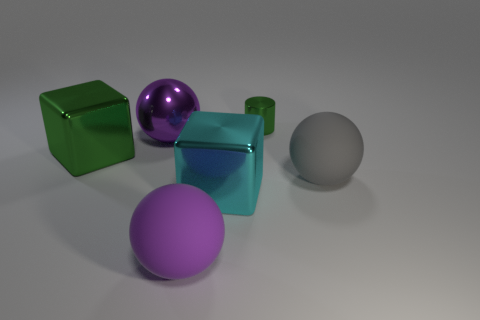What number of gray things are rubber spheres or big matte cylinders?
Your answer should be compact. 1. What is the color of the large metal sphere?
Ensure brevity in your answer.  Purple. The cyan block that is made of the same material as the green cube is what size?
Your response must be concise. Large. What number of other purple things have the same shape as the purple metallic object?
Provide a short and direct response. 1. Are there any other things that have the same size as the metallic cylinder?
Keep it short and to the point. No. What size is the cyan object that is left of the matte object behind the big purple matte object?
Provide a succinct answer. Large. What material is the green thing that is the same size as the purple matte thing?
Provide a short and direct response. Metal. Is there a green cube made of the same material as the tiny cylinder?
Provide a succinct answer. Yes. What is the color of the large matte ball that is in front of the cube in front of the block that is on the left side of the big purple shiny ball?
Offer a terse response. Purple. There is a ball that is left of the large purple rubber object; is its color the same as the rubber thing on the left side of the big gray rubber thing?
Ensure brevity in your answer.  Yes. 